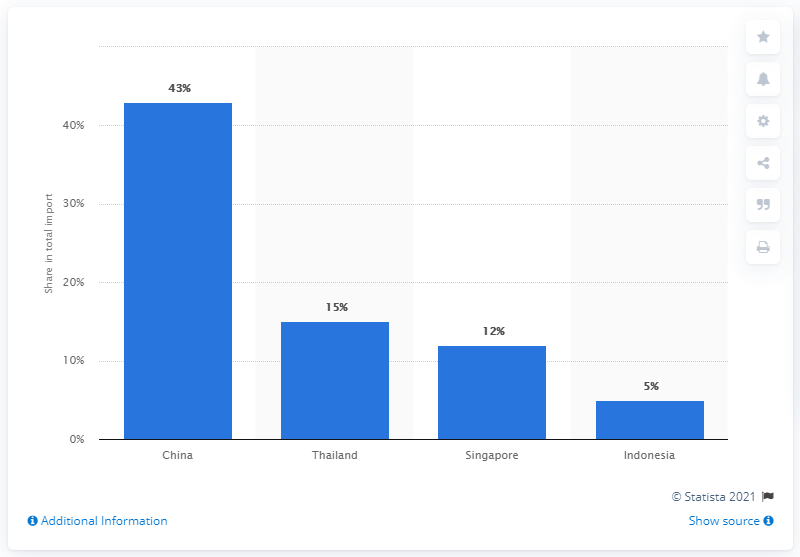Draw attention to some important aspects in this diagram. According to data from 2019, China was the primary import partner for Burma. 